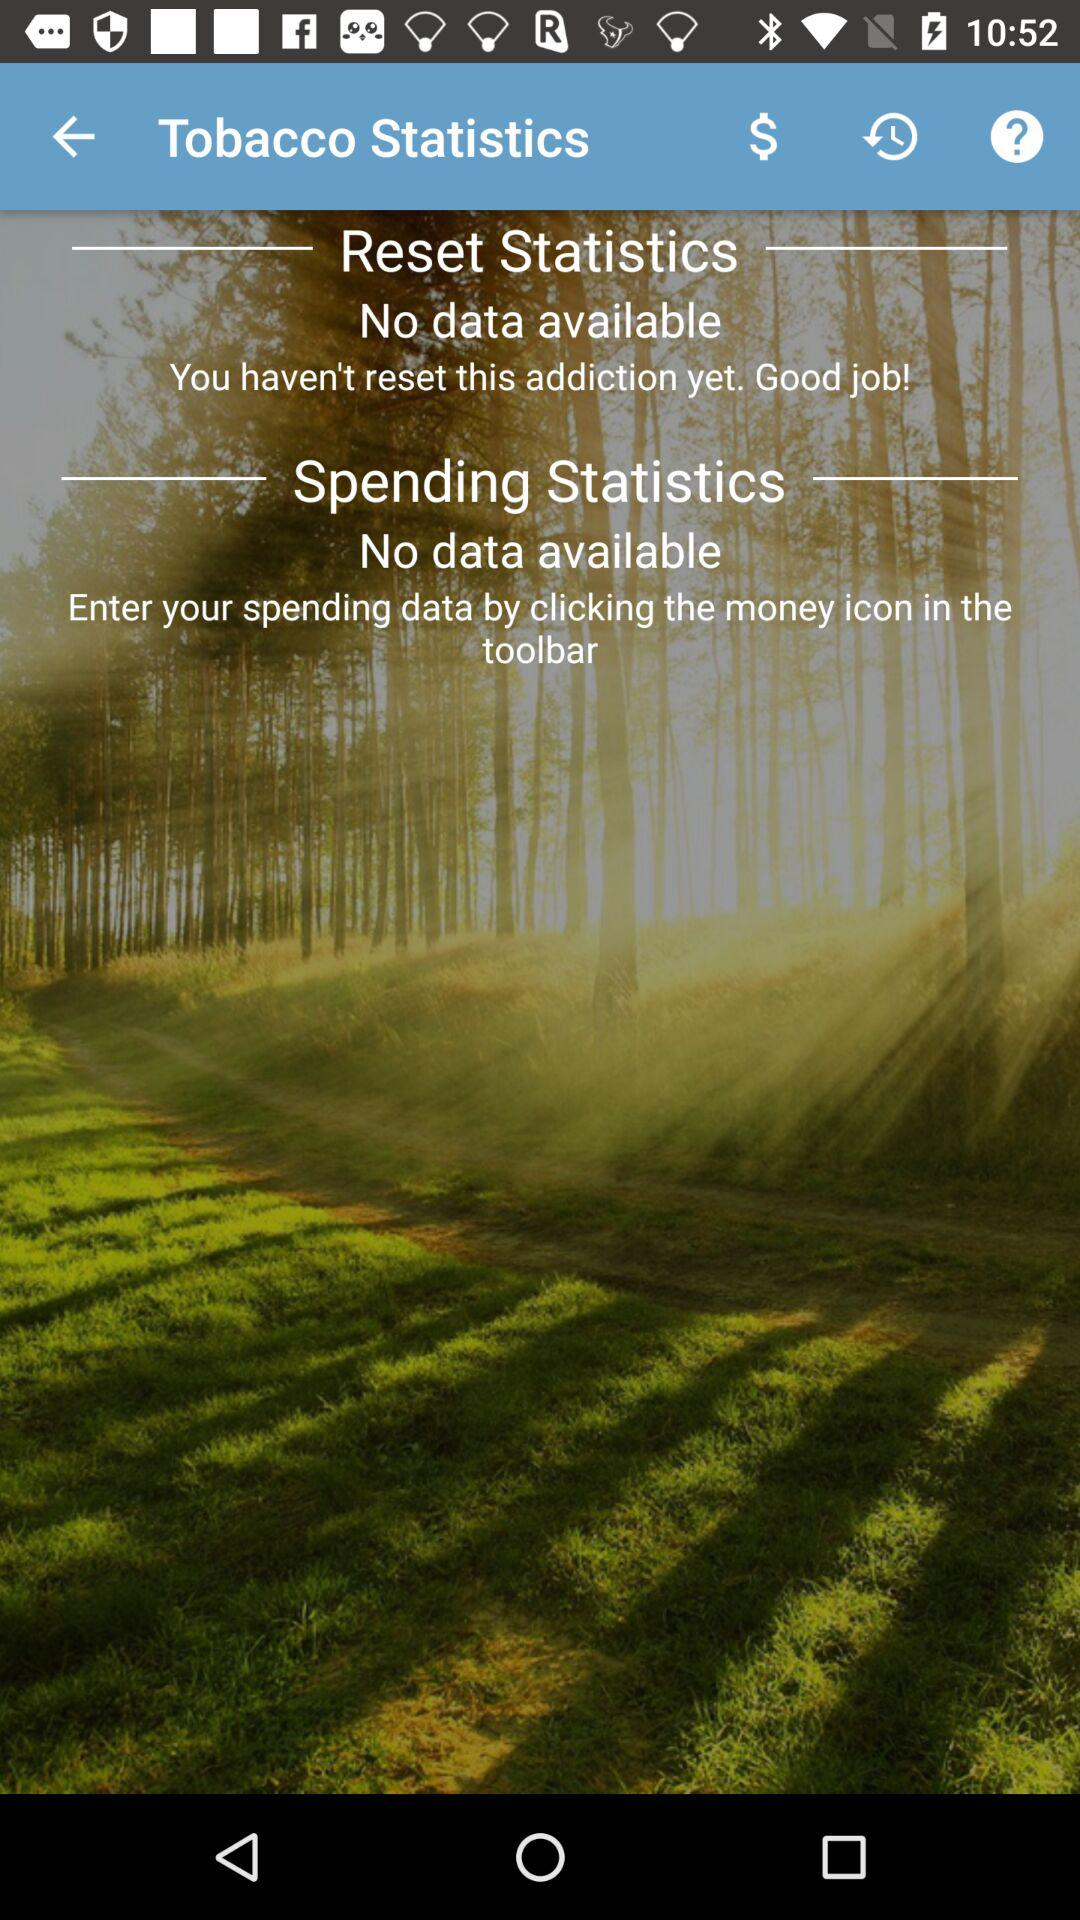How many statistics are shown for tobacco? The screen displays two sections for tobacco-related statistics: one for 'Reset Statistics' and another for 'Spending Statistics.' However, both sections currently indicate that there's 'No data available', suggesting that no spending has been recorded and there's been no need to reset the statistics, which could be seen as a positive indication of no tobacco use. 